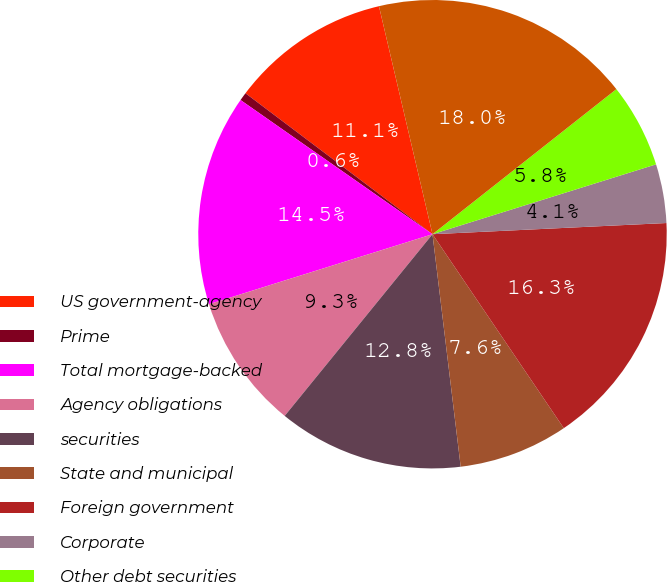<chart> <loc_0><loc_0><loc_500><loc_500><pie_chart><fcel>US government-agency<fcel>Prime<fcel>Total mortgage-backed<fcel>Agency obligations<fcel>securities<fcel>State and municipal<fcel>Foreign government<fcel>Corporate<fcel>Other debt securities<fcel>Total debt securities<nl><fcel>11.05%<fcel>0.57%<fcel>14.54%<fcel>9.3%<fcel>12.79%<fcel>7.55%<fcel>16.29%<fcel>4.06%<fcel>5.81%<fcel>18.04%<nl></chart> 